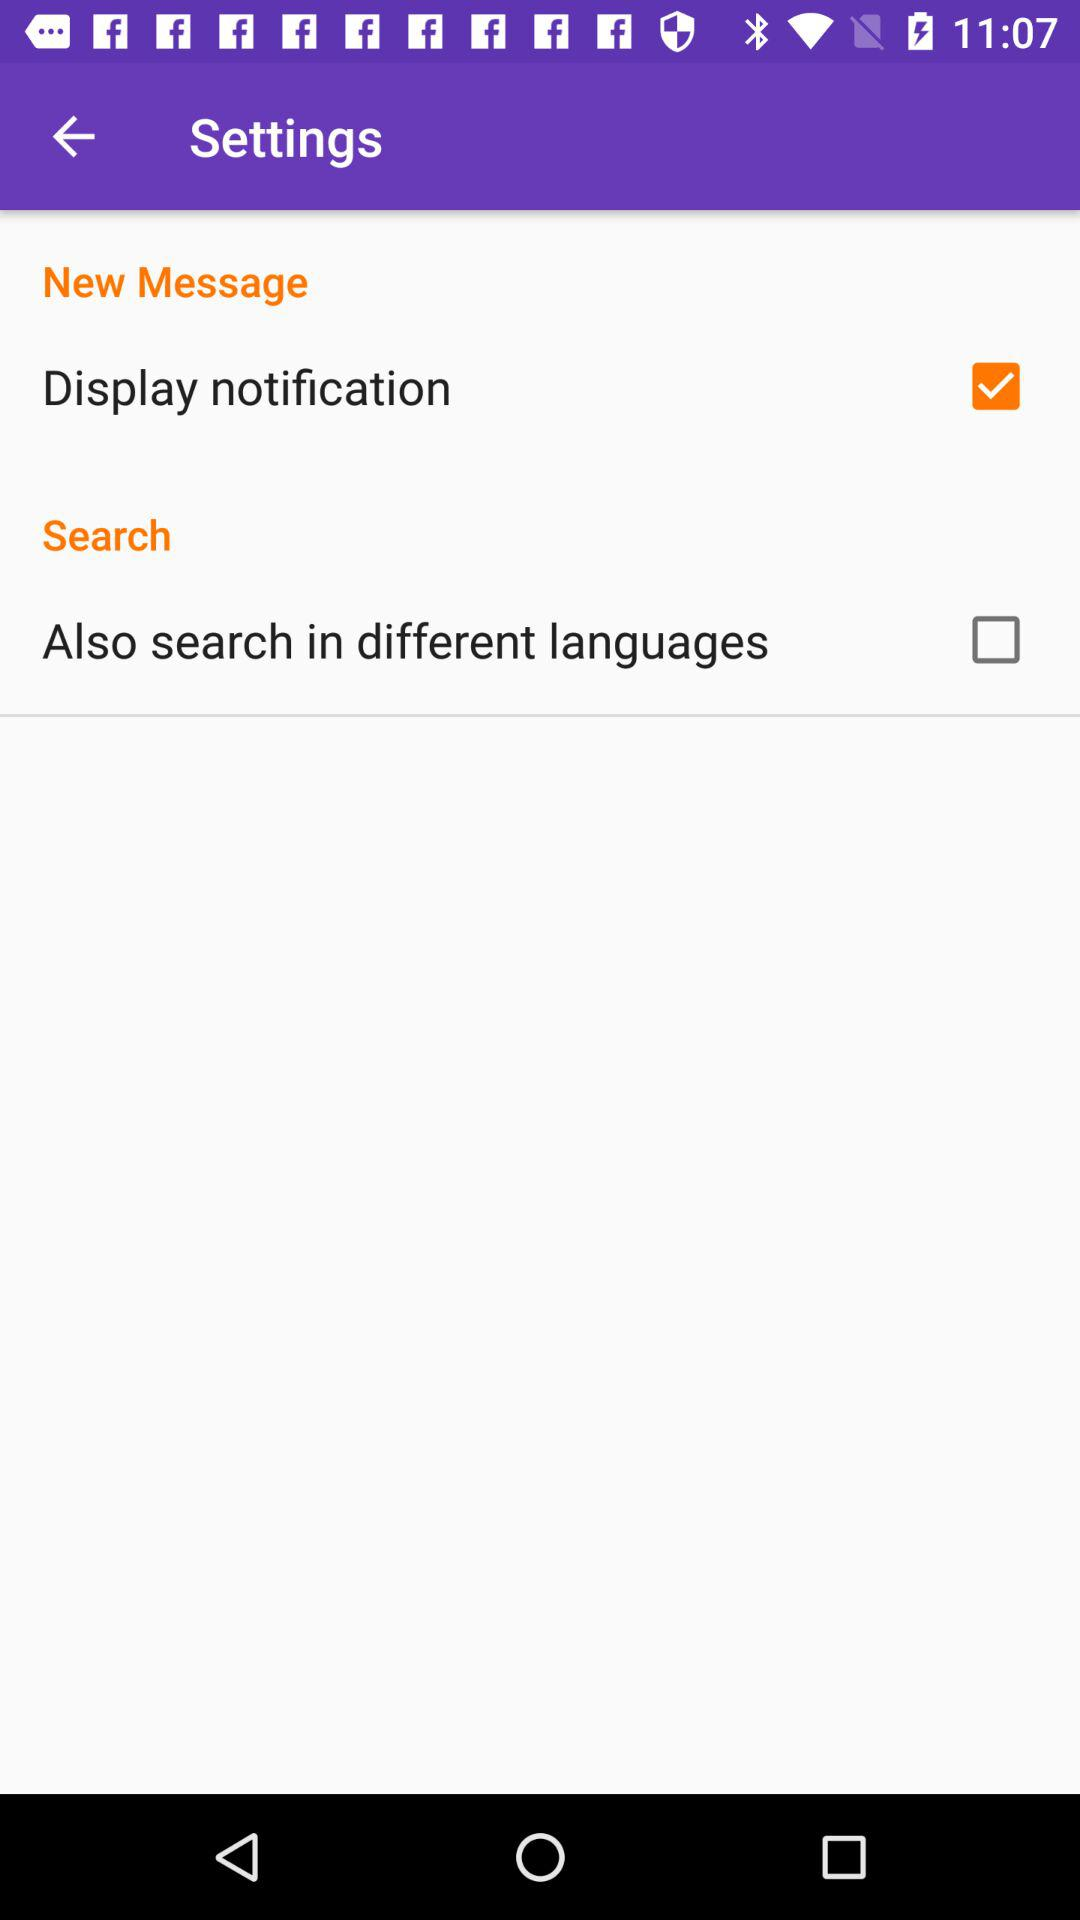What is the status of the "Display notification"? The status is "on". 